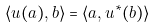Convert formula to latex. <formula><loc_0><loc_0><loc_500><loc_500>\langle u ( a ) , b \rangle = \langle a , u ^ { * } ( b ) \rangle</formula> 